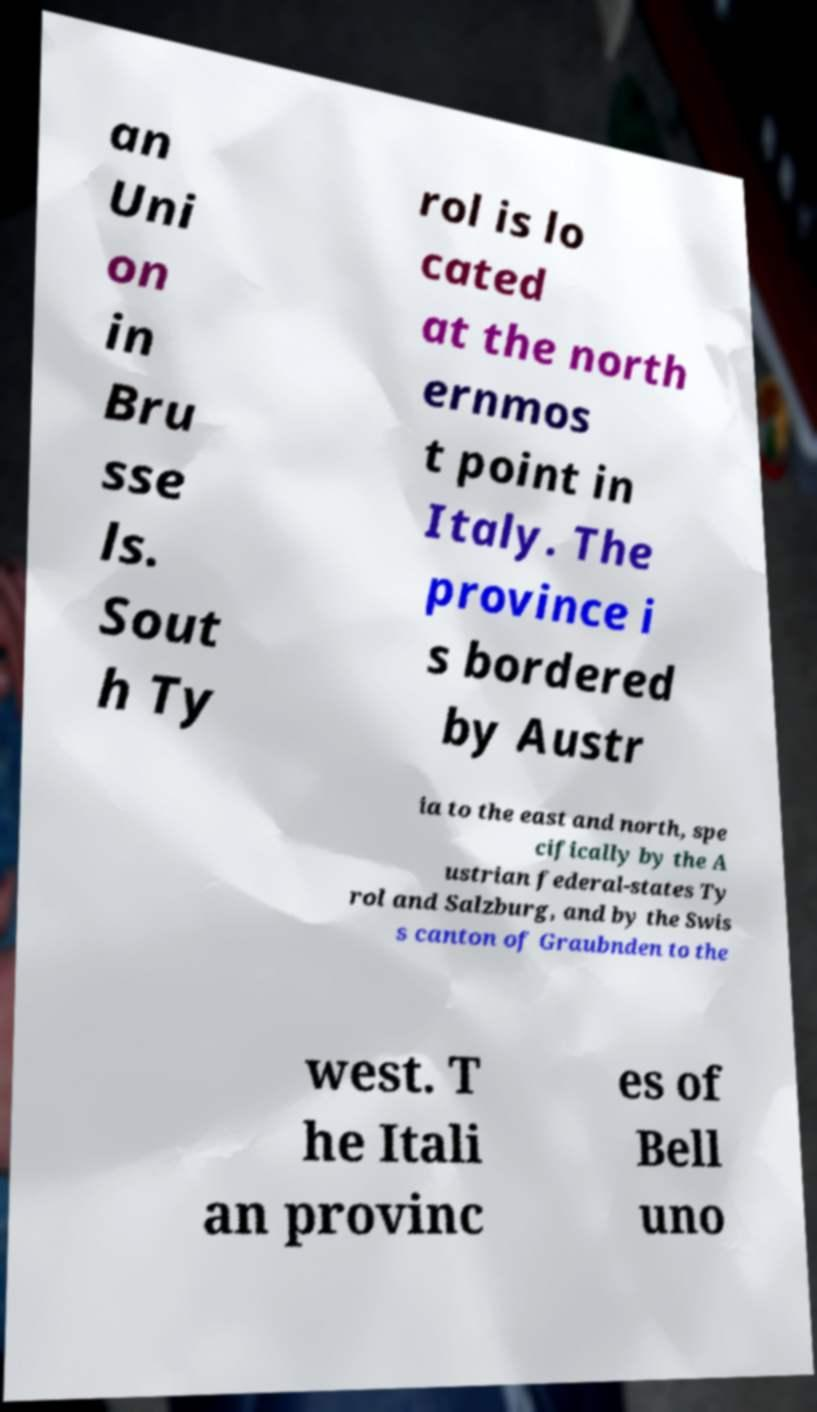There's text embedded in this image that I need extracted. Can you transcribe it verbatim? an Uni on in Bru sse ls. Sout h Ty rol is lo cated at the north ernmos t point in Italy. The province i s bordered by Austr ia to the east and north, spe cifically by the A ustrian federal-states Ty rol and Salzburg, and by the Swis s canton of Graubnden to the west. T he Itali an provinc es of Bell uno 